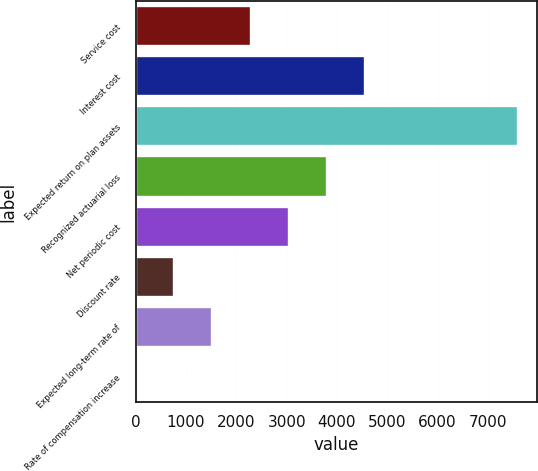Convert chart to OTSL. <chart><loc_0><loc_0><loc_500><loc_500><bar_chart><fcel>Service cost<fcel>Interest cost<fcel>Expected return on plan assets<fcel>Recognized actuarial loss<fcel>Net periodic cost<fcel>Discount rate<fcel>Expected long-term rate of<fcel>Rate of compensation increase<nl><fcel>2283.1<fcel>4562.2<fcel>7601<fcel>3802.5<fcel>3042.8<fcel>763.7<fcel>1523.4<fcel>4<nl></chart> 